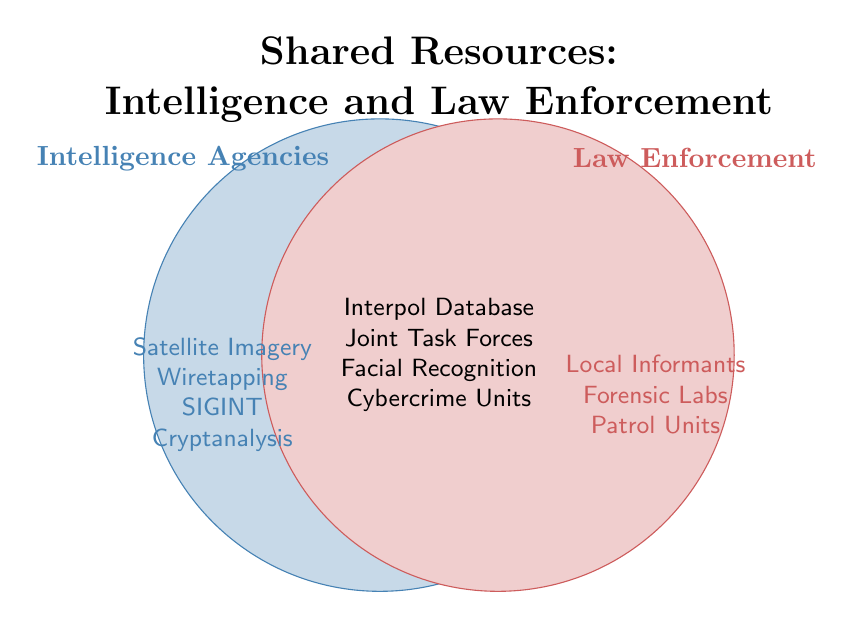1. What are the shared resources between Intelligence and Law Enforcement agencies? The shared resources are located in the overlapping part of the Venn diagram where both circles intersect. It lists Interpol Database, Joint Task Forces, Facial Recognition, and Cybercrime Units.
Answer: Interpol Database, Joint Task Forces, Facial Recognition, Cybercrime Units 2. Which category has more unique resources listed, Intelligence Agencies or Law Enforcement? By counting the items in the unique sections of each circle, Intelligence Agencies has 4 (Satellite Imagery, Wiretapping, SIGINT, Cryptanalysis) and Law Enforcement has 3 (Local Informants, Forensic Labs, Patrol Units).
Answer: Intelligence Agencies 3. What unique resource is available exclusively to Law Enforcement? The unique resources in the Law Enforcement section include Local Informants, Forensic Labs, and Patrol Units.
Answer: Local Informants, Forensic Labs, Patrol Units 4. How many resources in total are listed in the diagram? Count the number of unique resources in both circles and the shared region together. Intelligence Agencies (4) + Law Enforcement (3) + Shared (4) = 11.
Answer: 11 5. Compare the number of resources related only to Intelligence Agencies to the number of shared resources. Which is greater? The unique resources for Intelligence Agencies are 4, and the shared resources are also 4.
Answer: Equal 6. Which unique resource listed is used by Intelligence Agencies but not by Law Enforcement? The unique resources in the Intelligence Agencies section include Satellite Imagery, Wiretapping, SIGINT, and Cryptanalysis.
Answer: Satellite Imagery, Wiretapping, SIGINT, Cryptanalysis 7. Are there more shared resources or unique resources for Law Enforcement agencies? The number of shared resources is 4, and the unique resources for Law Enforcement is 3. The shared resources are greater.
Answer: Shared resources 8. How many types of resources do not overlap between Intelligence and Law Enforcement agencies? Count the unique resources for each section excluding the shared ones. Intelligence Agencies (4) + Law Enforcement (3) = 7.
Answer: 7 